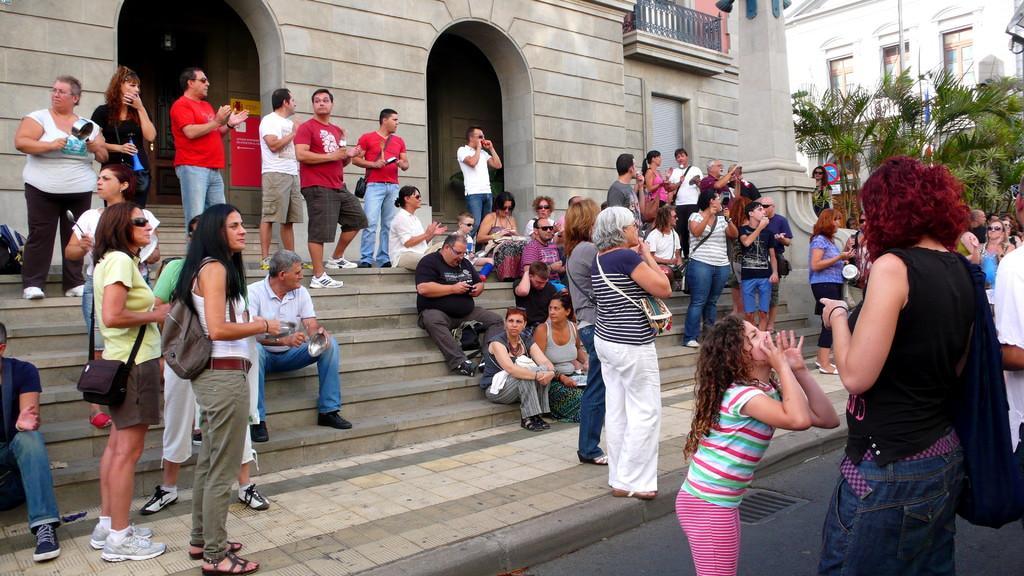Can you describe this image briefly? In the picture we can see a building with a stairs in front of it with some people sitting on it and some people are standing and discussing something and near the stairs we can see a road on it also we can see some people are standing and inside the building we can see some plants and another building with windows to it. 